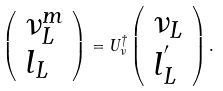<formula> <loc_0><loc_0><loc_500><loc_500>\left ( \begin{array} { l } { { \nu _ { L } ^ { m } } } \\ { { l _ { L } } } \end{array} \right ) = U _ { \nu } ^ { \dagger } \left ( \begin{array} { l } { { \nu _ { L } } } \\ { { l _ { L } ^ { ^ { \prime } } } } \end{array} \right ) .</formula> 